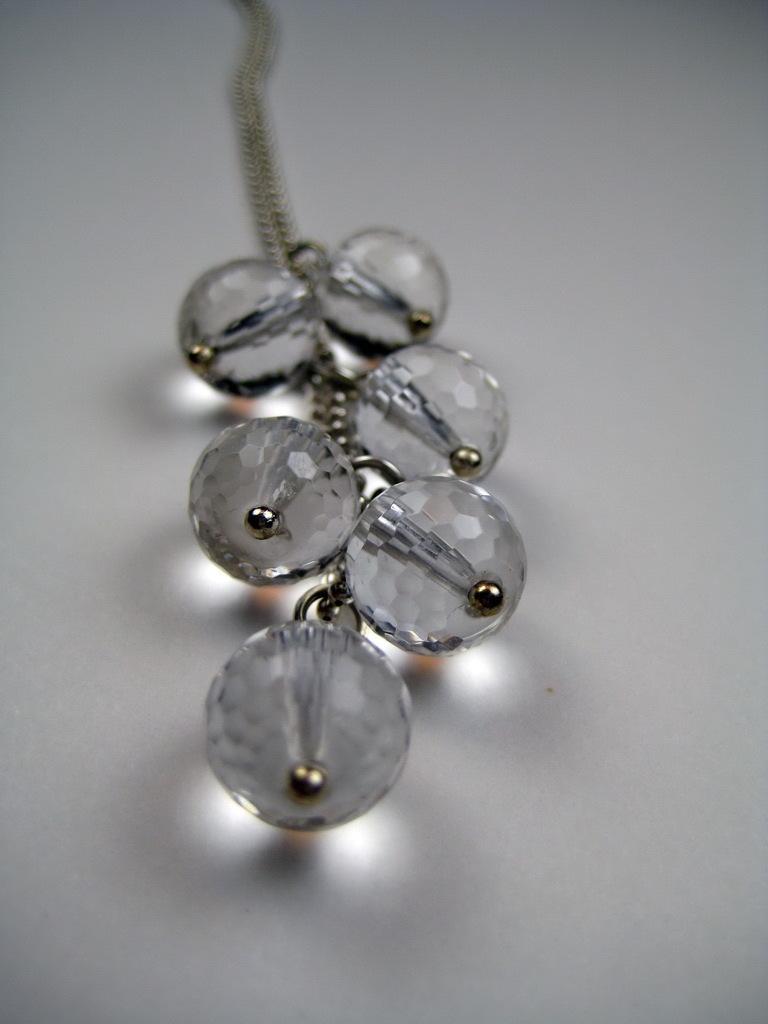Please provide a concise description of this image. In this image there are some stones attached to the chain, background is white. 